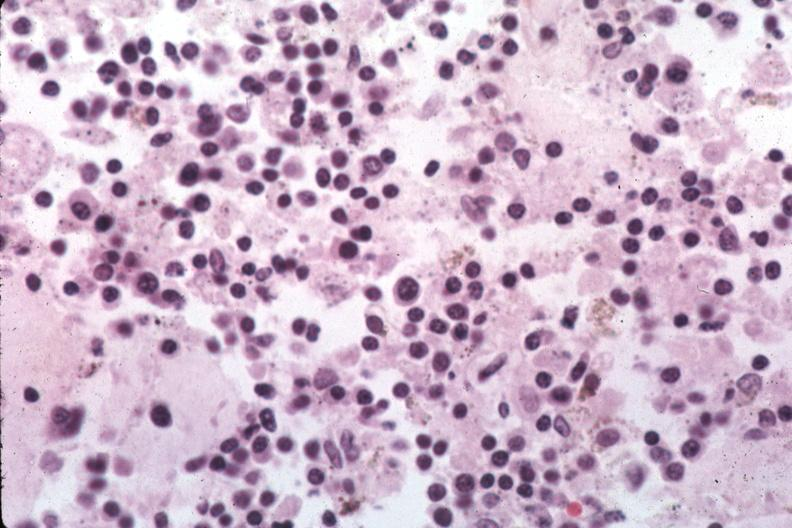how are organisms easily?
Answer the question using a single word or phrase. Evident 